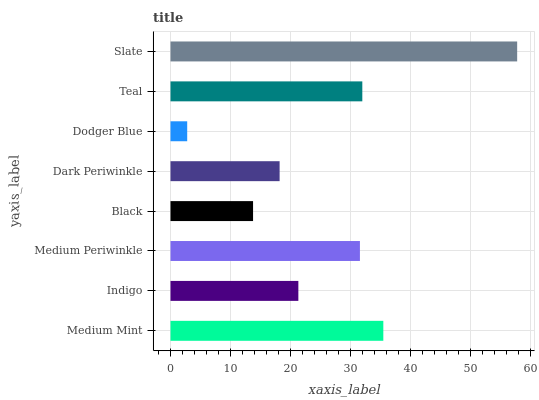Is Dodger Blue the minimum?
Answer yes or no. Yes. Is Slate the maximum?
Answer yes or no. Yes. Is Indigo the minimum?
Answer yes or no. No. Is Indigo the maximum?
Answer yes or no. No. Is Medium Mint greater than Indigo?
Answer yes or no. Yes. Is Indigo less than Medium Mint?
Answer yes or no. Yes. Is Indigo greater than Medium Mint?
Answer yes or no. No. Is Medium Mint less than Indigo?
Answer yes or no. No. Is Medium Periwinkle the high median?
Answer yes or no. Yes. Is Indigo the low median?
Answer yes or no. Yes. Is Indigo the high median?
Answer yes or no. No. Is Dark Periwinkle the low median?
Answer yes or no. No. 